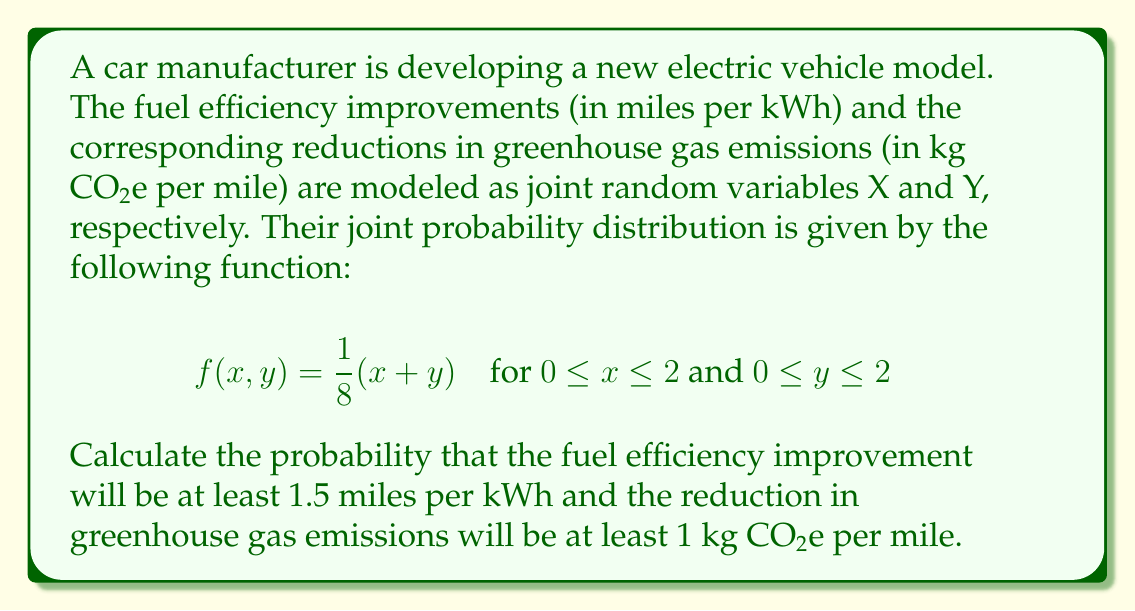Could you help me with this problem? To solve this problem, we need to integrate the joint probability density function over the specified region. Let's break it down step-by-step:

1) The region we're interested in is:
   $1.5 \leq x \leq 2$ and $1 \leq y \leq 2$

2) We need to calculate:
   $$P(X \geq 1.5, Y \geq 1) = \int_{1.5}^2 \int_1^2 f(x,y) dy dx$$

3) Substituting the given function:
   $$P(X \geq 1.5, Y \geq 1) = \int_{1.5}^2 \int_1^2 \frac{1}{8}(x+y) dy dx$$

4) Let's solve the inner integral first:
   $$\int_1^2 \frac{1}{8}(x+y) dy = \frac{1}{8}[xy + \frac{y^2}{2}]_1^2$$
   $$= \frac{1}{8}[(2x + 2) - (x + \frac{1}{2})] = \frac{1}{8}(x + \frac{3}{2})$$

5) Now, let's solve the outer integral:
   $$\int_{1.5}^2 \frac{1}{8}(x + \frac{3}{2}) dx = \frac{1}{8}[\frac{x^2}{2} + \frac{3x}{2}]_{1.5}^2$$
   $$= \frac{1}{8}[(2 + 3) - (\frac{9}{8} + \frac{9}{4})] = \frac{1}{8}(5 - \frac{27}{8}) = \frac{13}{64}$$

Therefore, the probability that the fuel efficiency improvement will be at least 1.5 miles per kWh and the reduction in greenhouse gas emissions will be at least 1 kg CO2e per mile is $\frac{13}{64}$.
Answer: $\frac{13}{64}$ 